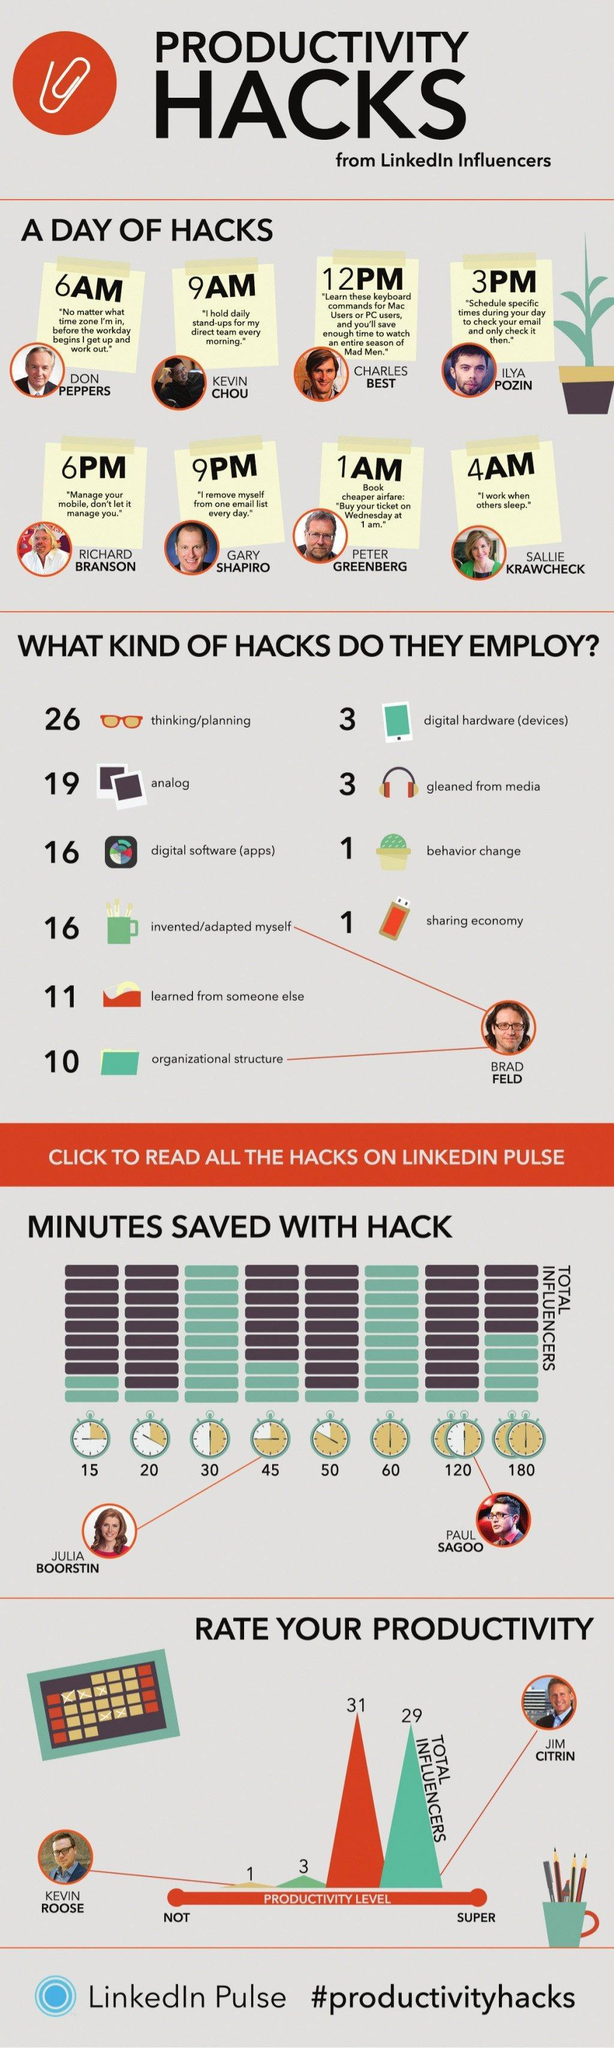How many minutes did Paul Sagoo save with Hack
Answer the question with a short phrase. 120 At what time is the hack of Kevin Chou 9 AM What are the hacks of Brad Feld invented/adapted myself, organizational structure What is the 4AM Hack "I work when others sleep." How many minutes did Julia Boorstin save with Hack 45 Who recommends to buy ticket on Wednesday at 1 am Peter Greenberg Who says that the mobile should not manage us Richard Branson 